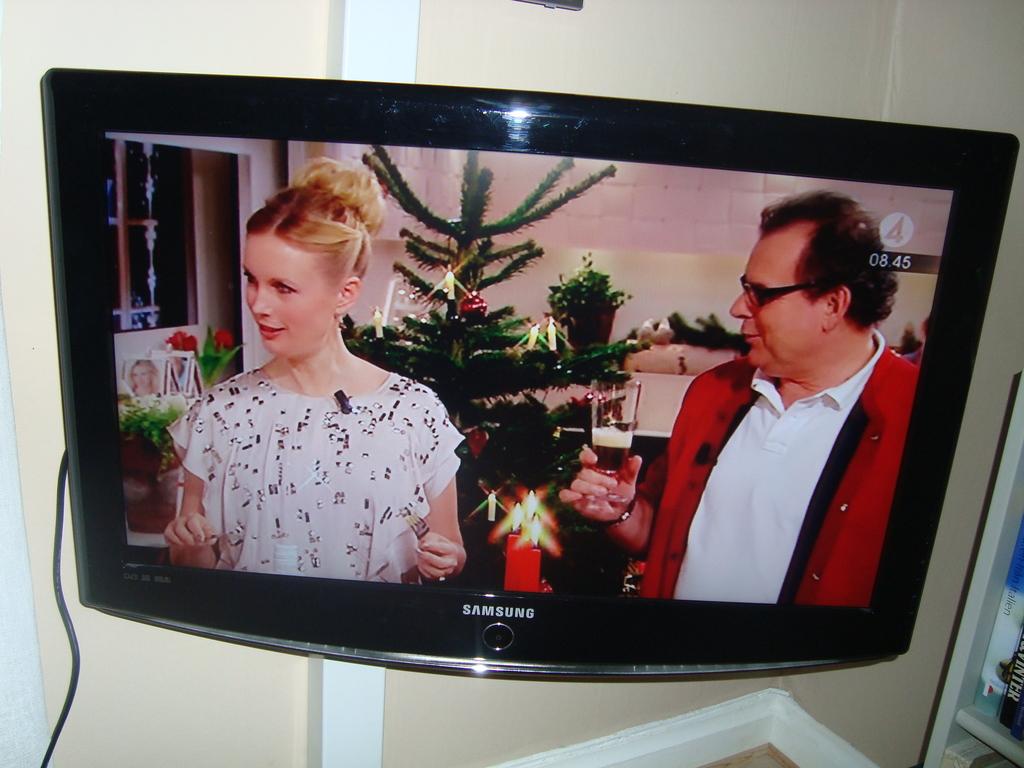What brand is this television?
Give a very brief answer. Samsung. What channel is this show on?
Your answer should be very brief. 4. 